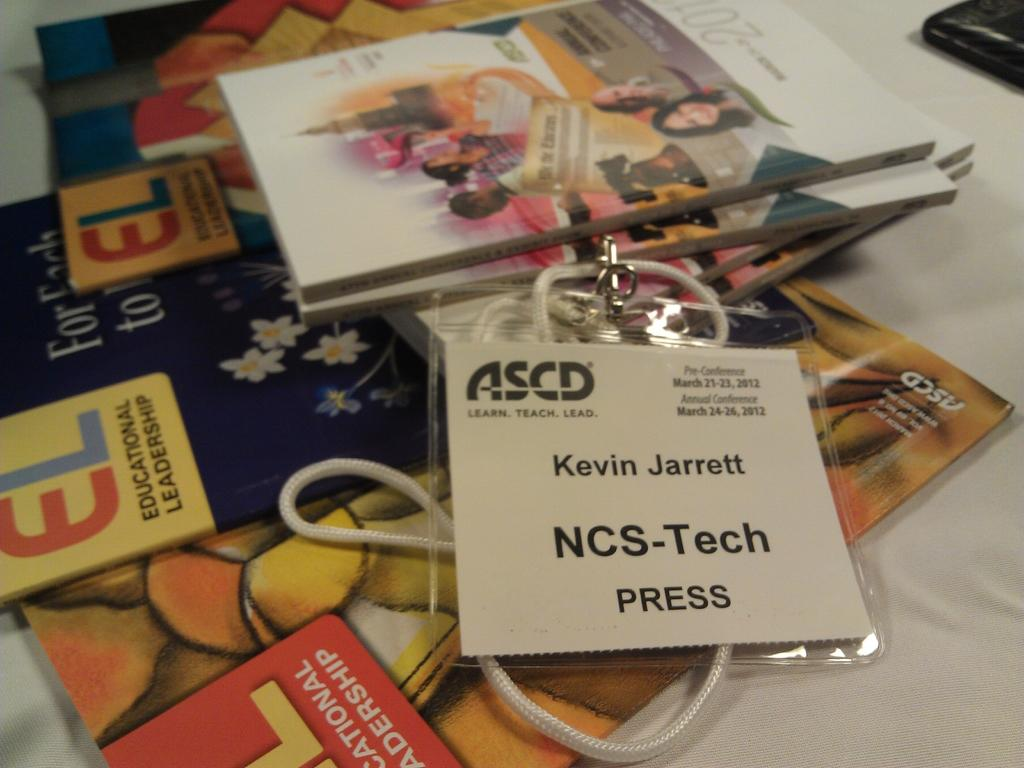<image>
Summarize the visual content of the image. A badge for Kevin Jarrett, NCS-Tech, on top of several ASCD materials. 